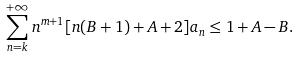<formula> <loc_0><loc_0><loc_500><loc_500>\sum ^ { + \infty } _ { n = k } n ^ { m + 1 } [ n ( B + 1 ) + A + 2 ] a _ { n } \leq 1 + A - B .</formula> 